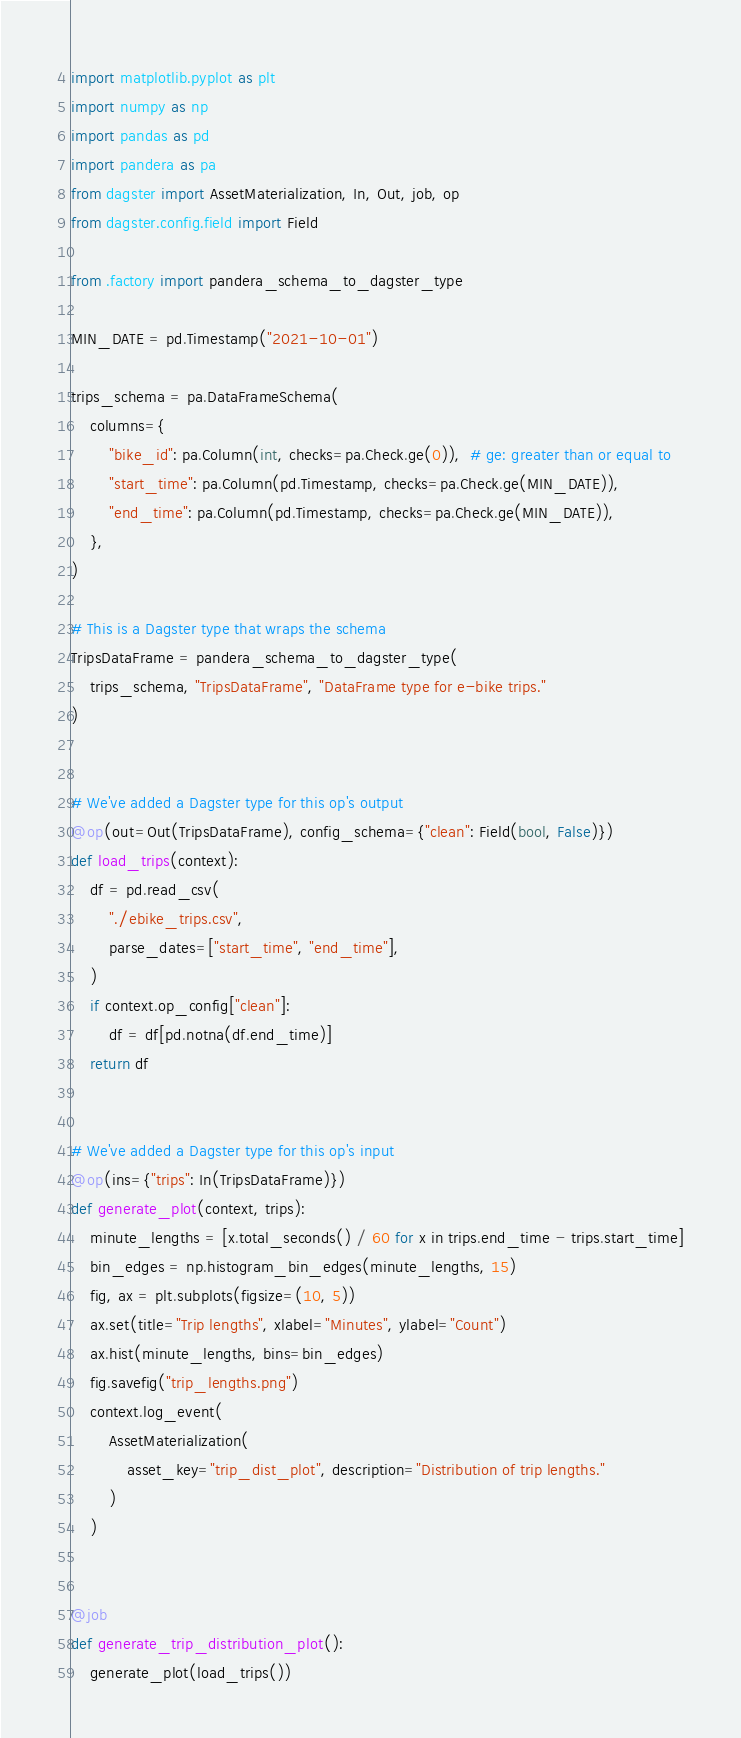<code> <loc_0><loc_0><loc_500><loc_500><_Python_>import matplotlib.pyplot as plt
import numpy as np
import pandas as pd
import pandera as pa
from dagster import AssetMaterialization, In, Out, job, op
from dagster.config.field import Field

from .factory import pandera_schema_to_dagster_type

MIN_DATE = pd.Timestamp("2021-10-01")

trips_schema = pa.DataFrameSchema(
    columns={
        "bike_id": pa.Column(int, checks=pa.Check.ge(0)),  # ge: greater than or equal to
        "start_time": pa.Column(pd.Timestamp, checks=pa.Check.ge(MIN_DATE)),
        "end_time": pa.Column(pd.Timestamp, checks=pa.Check.ge(MIN_DATE)),
    },
)

# This is a Dagster type that wraps the schema
TripsDataFrame = pandera_schema_to_dagster_type(
    trips_schema, "TripsDataFrame", "DataFrame type for e-bike trips."
)


# We've added a Dagster type for this op's output
@op(out=Out(TripsDataFrame), config_schema={"clean": Field(bool, False)})
def load_trips(context):
    df = pd.read_csv(
        "./ebike_trips.csv",
        parse_dates=["start_time", "end_time"],
    )
    if context.op_config["clean"]:
        df = df[pd.notna(df.end_time)]
    return df


# We've added a Dagster type for this op's input
@op(ins={"trips": In(TripsDataFrame)})
def generate_plot(context, trips):
    minute_lengths = [x.total_seconds() / 60 for x in trips.end_time - trips.start_time]
    bin_edges = np.histogram_bin_edges(minute_lengths, 15)
    fig, ax = plt.subplots(figsize=(10, 5))
    ax.set(title="Trip lengths", xlabel="Minutes", ylabel="Count")
    ax.hist(minute_lengths, bins=bin_edges)
    fig.savefig("trip_lengths.png")
    context.log_event(
        AssetMaterialization(
            asset_key="trip_dist_plot", description="Distribution of trip lengths."
        )
    )


@job
def generate_trip_distribution_plot():
    generate_plot(load_trips())
</code> 